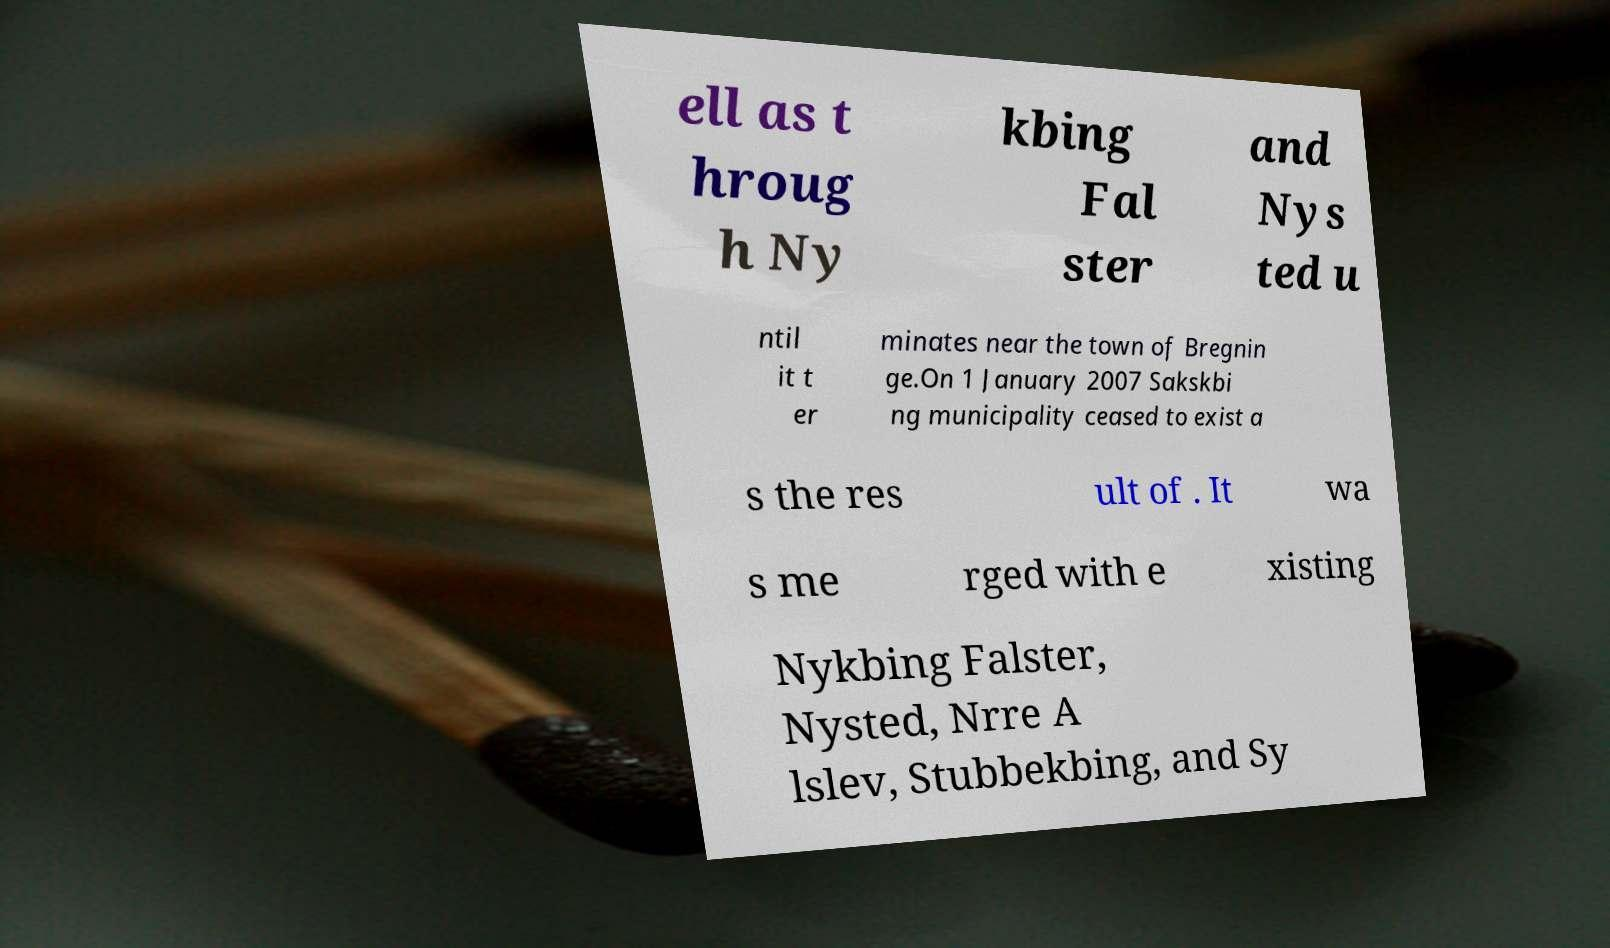There's text embedded in this image that I need extracted. Can you transcribe it verbatim? ell as t hroug h Ny kbing Fal ster and Nys ted u ntil it t er minates near the town of Bregnin ge.On 1 January 2007 Sakskbi ng municipality ceased to exist a s the res ult of . It wa s me rged with e xisting Nykbing Falster, Nysted, Nrre A lslev, Stubbekbing, and Sy 